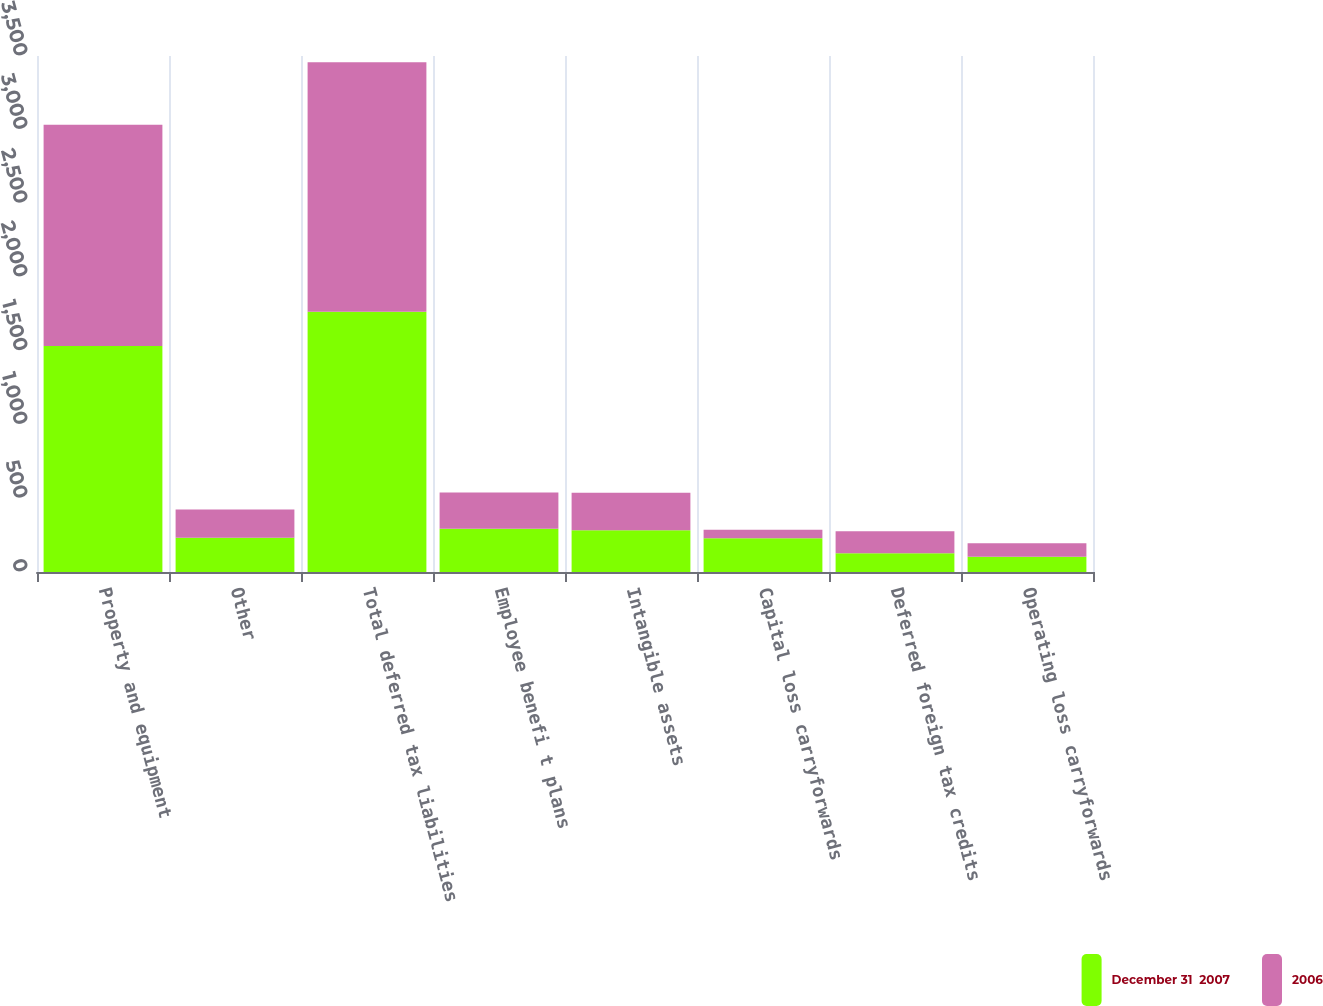<chart> <loc_0><loc_0><loc_500><loc_500><stacked_bar_chart><ecel><fcel>Property and equipment<fcel>Other<fcel>Total deferred tax liabilities<fcel>Employee benefi t plans<fcel>Intangible assets<fcel>Capital loss carryforwards<fcel>Deferred foreign tax credits<fcel>Operating loss carryforwards<nl><fcel>December 31  2007<fcel>1532.7<fcel>231.8<fcel>1764.5<fcel>292.8<fcel>282.4<fcel>228.3<fcel>127.2<fcel>102.6<nl><fcel>2006<fcel>1500.2<fcel>192.7<fcel>1692.9<fcel>247.1<fcel>255.1<fcel>58.4<fcel>149.3<fcel>92.9<nl></chart> 